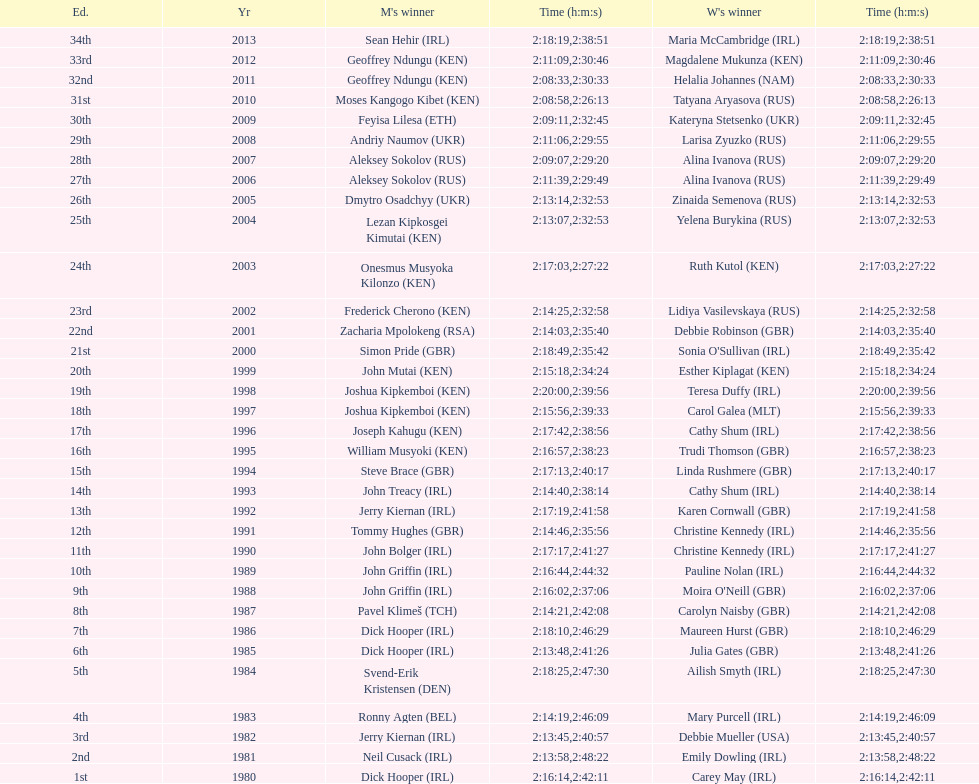Who possessed the most time out of all the participants? Maria McCambridge (IRL). 